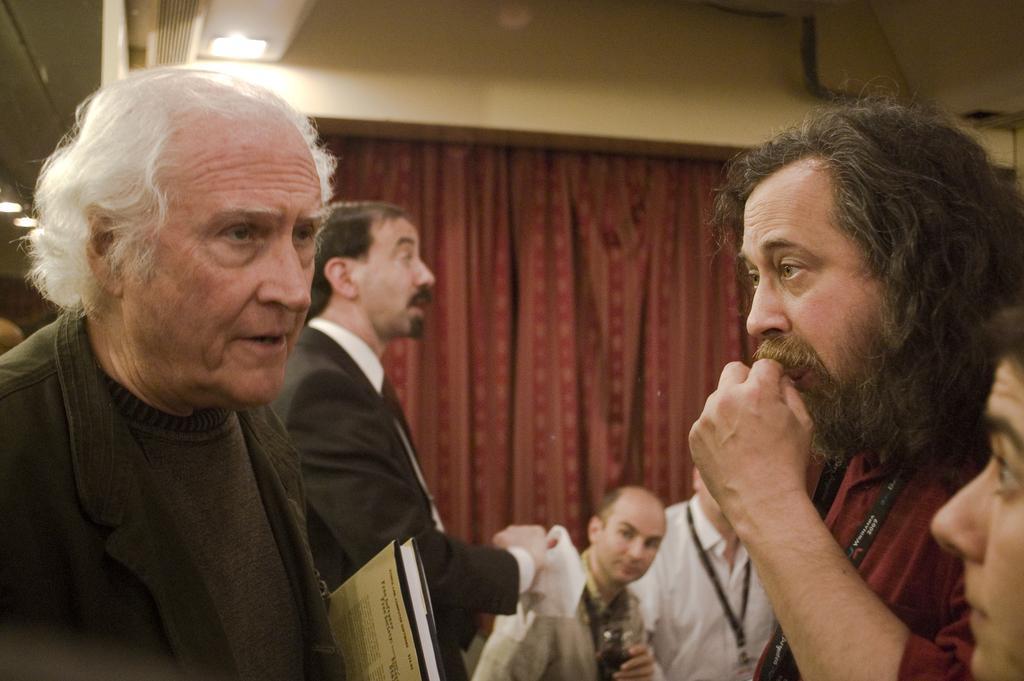Can you describe this image briefly? In this picture we can see people, here we can see files and some objects and in the background we can see a curtain, lights, wall and some objects. 